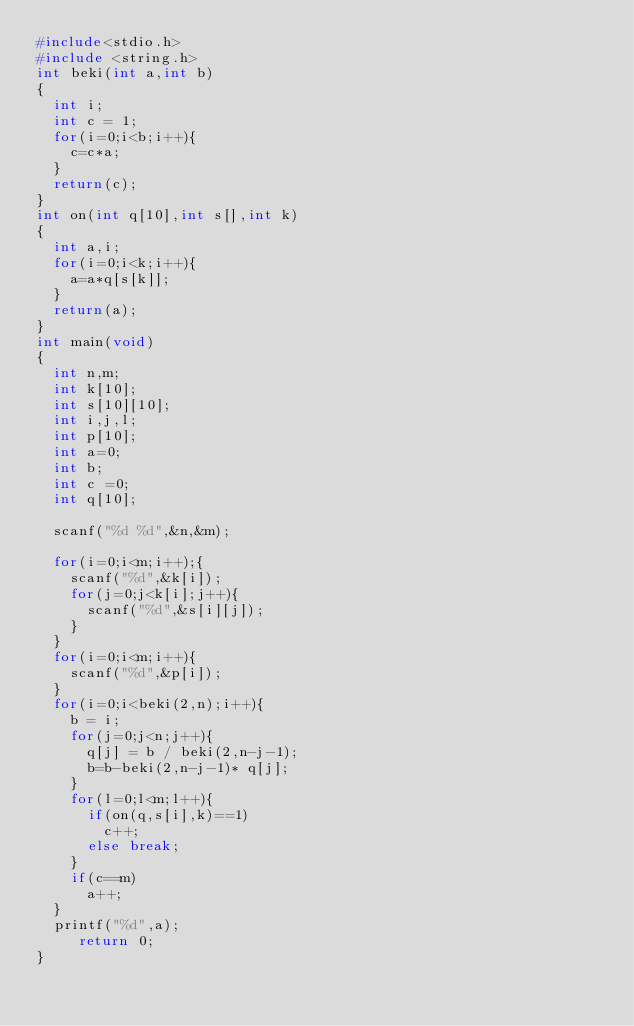<code> <loc_0><loc_0><loc_500><loc_500><_C_>#include<stdio.h>
#include <string.h>
int beki(int a,int b)
{
  int i;
  int c = 1;
  for(i=0;i<b;i++){
    c=c*a;
  }
  return(c);
}
int on(int q[10],int s[],int k)
{
  int a,i;
  for(i=0;i<k;i++){
    a=a*q[s[k]];
  }
  return(a);
}
int main(void)
{
  int n,m;
  int k[10];
  int s[10][10];
  int i,j,l;
  int p[10];
  int a=0;
  int b;
  int c =0;
  int q[10];
  
  scanf("%d %d",&n,&m);
  
  for(i=0;i<m;i++);{
    scanf("%d",&k[i]);
    for(j=0;j<k[i];j++){
      scanf("%d",&s[i][j]);
    }
  }
  for(i=0;i<m;i++){
    scanf("%d",&p[i]);
  }
  for(i=0;i<beki(2,n);i++){
    b = i;
    for(j=0;j<n;j++){
      q[j] = b / beki(2,n-j-1);
      b=b-beki(2,n-j-1)* q[j];
    }
    for(l=0;l<m;l++){
      if(on(q,s[i],k)==1)
        c++;
      else break;
    }
    if(c==m)
      a++;
  }
  printf("%d",a);
     return 0;
}</code> 